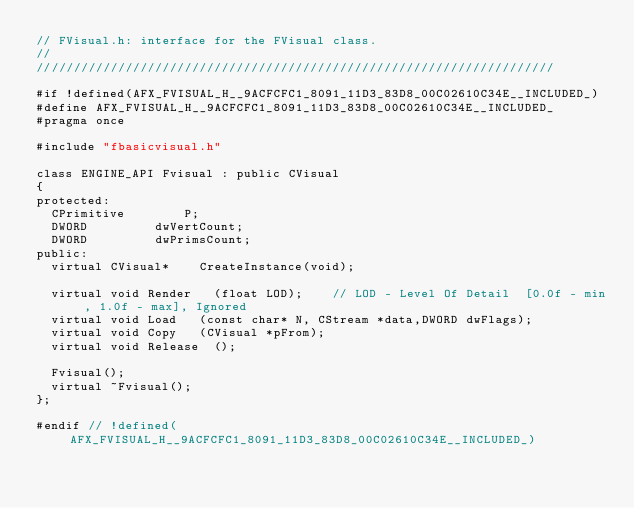Convert code to text. <code><loc_0><loc_0><loc_500><loc_500><_C_>// FVisual.h: interface for the FVisual class.
//
//////////////////////////////////////////////////////////////////////

#if !defined(AFX_FVISUAL_H__9ACFCFC1_8091_11D3_83D8_00C02610C34E__INCLUDED_)
#define AFX_FVISUAL_H__9ACFCFC1_8091_11D3_83D8_00C02610C34E__INCLUDED_
#pragma once

#include "fbasicvisual.h"

class ENGINE_API Fvisual : public CVisual
{
protected:
	CPrimitive				P;
	DWORD					dwVertCount;
	DWORD					dwPrimsCount;
public:
	virtual CVisual*		CreateInstance(void);

	virtual void Render		(float LOD);		// LOD - Level Of Detail  [0.0f - min, 1.0f - max], Ignored
	virtual void Load		(const char* N, CStream *data,DWORD dwFlags);
	virtual void Copy		(CVisual *pFrom);
	virtual void Release	();

	Fvisual();
	virtual ~Fvisual();
};

#endif // !defined(AFX_FVISUAL_H__9ACFCFC1_8091_11D3_83D8_00C02610C34E__INCLUDED_)
</code> 